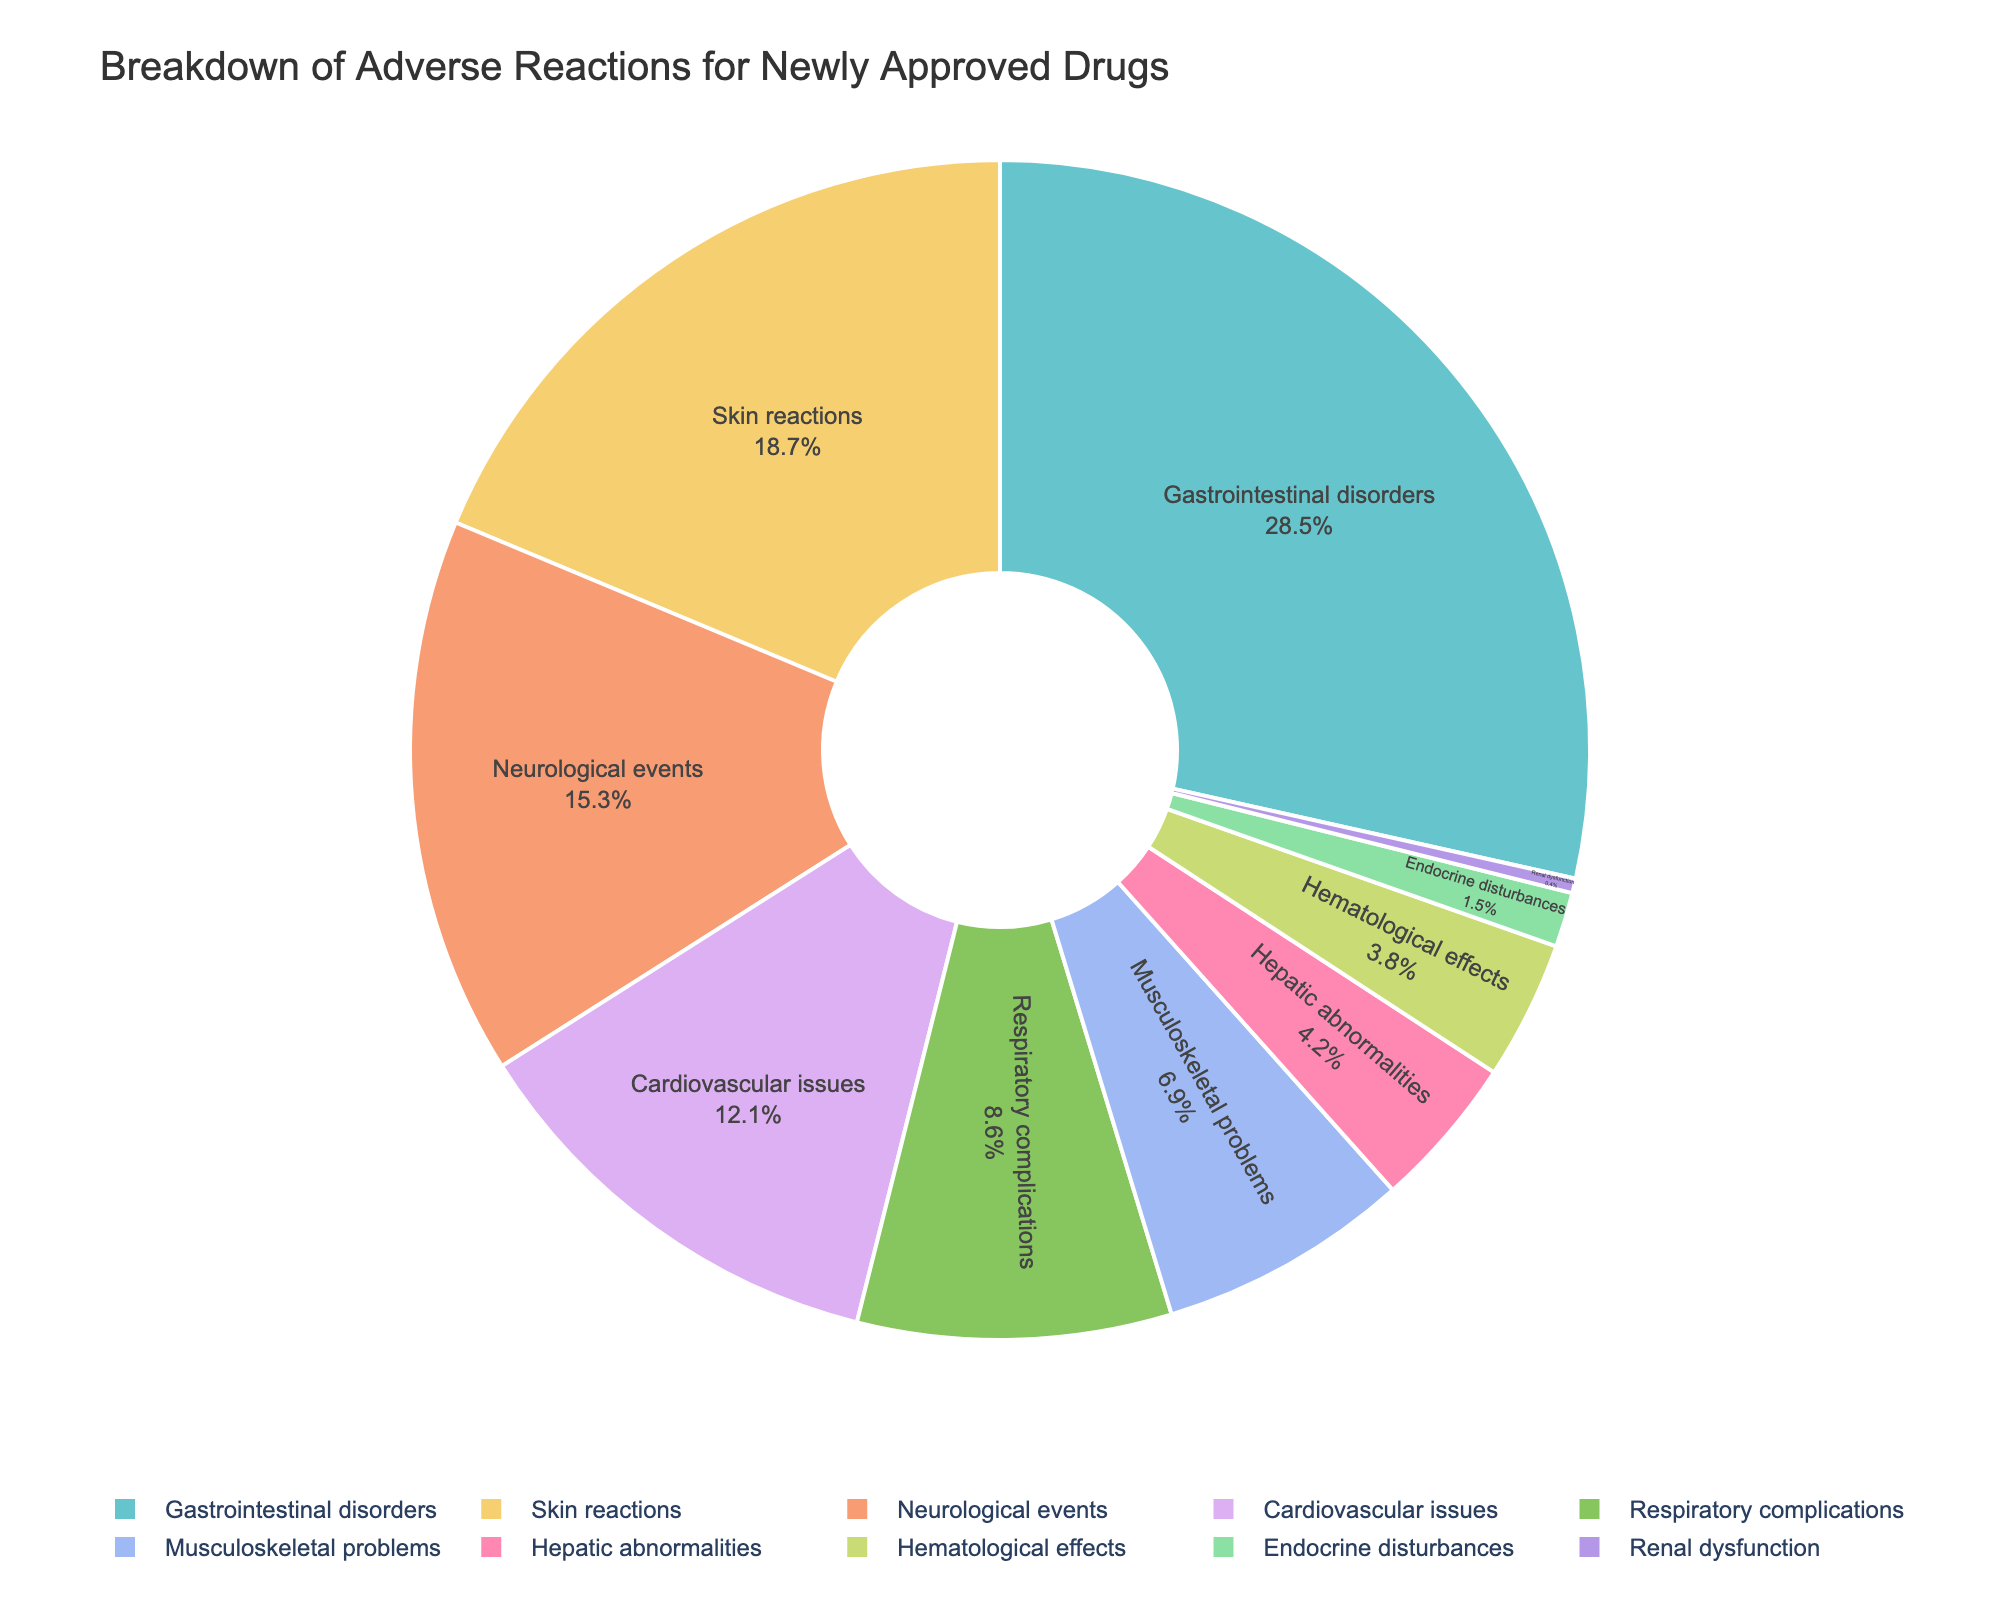What is the category with the highest percentage of adverse reactions? The category with the highest percentage can be identified by looking for the largest portion in the pie chart. The largest segment is labeled "Gastrointestinal disorders" with 28.5%.
Answer: Gastrointestinal disorders Which two categories have the smallest percentages of adverse reactions, and what are their combined percentages? The two categories with the smallest percentages are found by identifying the smallest pie segments. They are "Renal dysfunction" with 0.4% and "Endocrine disturbances" with 1.5%. Adding these two percentages together gives 0.4% + 1.5% = 1.9%.
Answer: Renal dysfunction and Endocrine disturbances, 1.9% By what percentage do Gastrointestinal disorders exceed Skin reactions in reported adverse reactions? The percentage for Gastrointestinal disorders is 28.5% and for Skin reactions is 18.7%. Subtracting the smaller percentage from the larger one gives 28.5% - 18.7% = 9.8%.
Answer: 9.8% Which categories account for less than 5% of the reported adverse reactions each? Looking at the pie chart, the categories with percentages less than 5% are the smallest segments: Hepatic abnormalities (4.2%), Hematological effects (3.8%), Endocrine disturbances (1.5%), Renal dysfunction (0.4%).
Answer: Hepatic abnormalities, Hematological effects, Endocrine disturbances, Renal dysfunction How much larger is the percentage of Neurological events compared to Respiratory complications? The percentage for Neurological events is 15.3% and for Respiratory complications is 8.6%. Subtracting these gives 15.3% - 8.6% = 6.7%.
Answer: 6.7% If you combine the percentages of Cardiovascular issues and Musculoskeletal problems, do they exceed the percentage of Gastrointestinal disorders? The percent for Cardiovascular issues is 12.1% and for Musculoskeletal problems is 6.9%. Their combined percentage is 12.1% + 6.9% = 19%, which is less than the 28.5% for Gastrointestinal disorders.
Answer: No Which category related to organ systems has the lowest reported adverse reactions? To identify the lowest among organ system categories, find the smallest pie segment relevant to an organ system. "Renal dysfunction" has the lowest percentage with 0.4%.
Answer: Renal dysfunction 